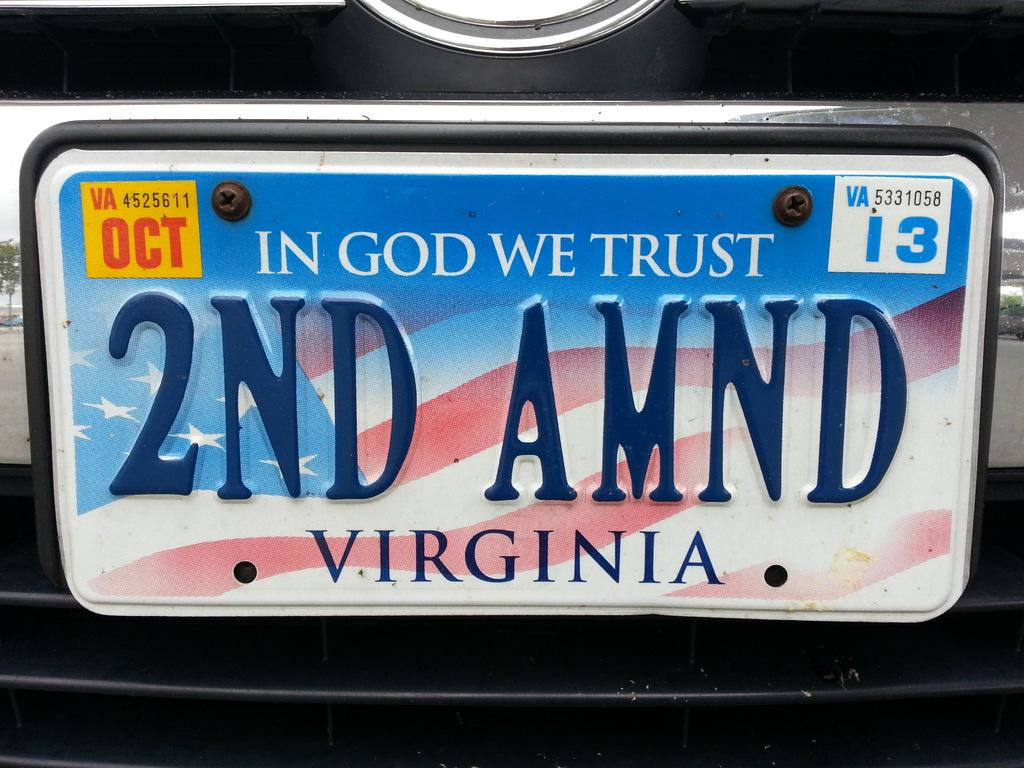<image>
Provide a brief description of the given image. A Viginia tag that reads 2ND AMND and expired in 2013. 